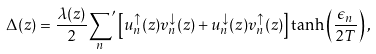Convert formula to latex. <formula><loc_0><loc_0><loc_500><loc_500>\Delta ( z ) = \frac { \lambda ( z ) } { 2 } { \sum _ { n } } ^ { \prime } \left [ u _ { n } ^ { \uparrow } ( z ) v _ { n } ^ { \downarrow } ( z ) + u _ { n } ^ { \downarrow } ( z ) v _ { n } ^ { \uparrow } ( z ) \right ] \tanh \left ( \frac { \epsilon _ { n } } { 2 T } \right ) ,</formula> 